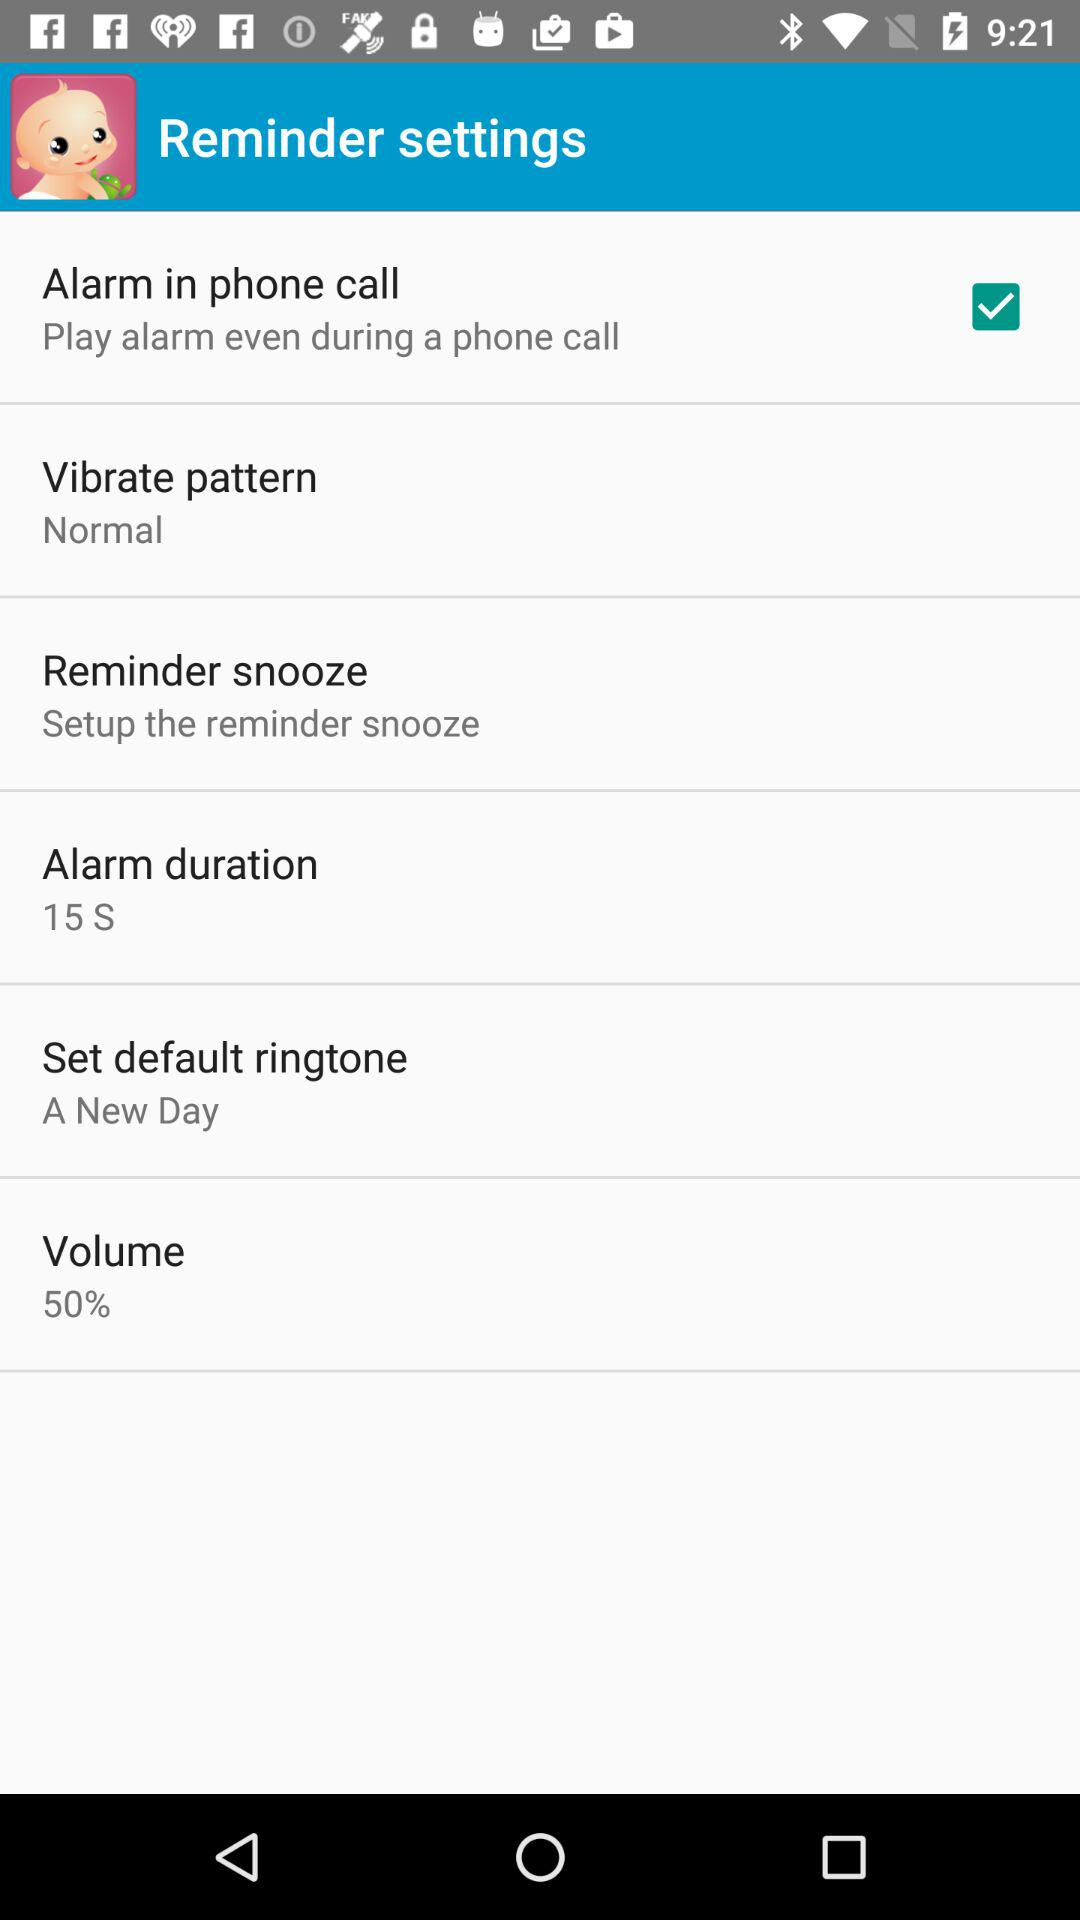What is the volume of the alarm set to?
Answer the question using a single word or phrase. 50% 